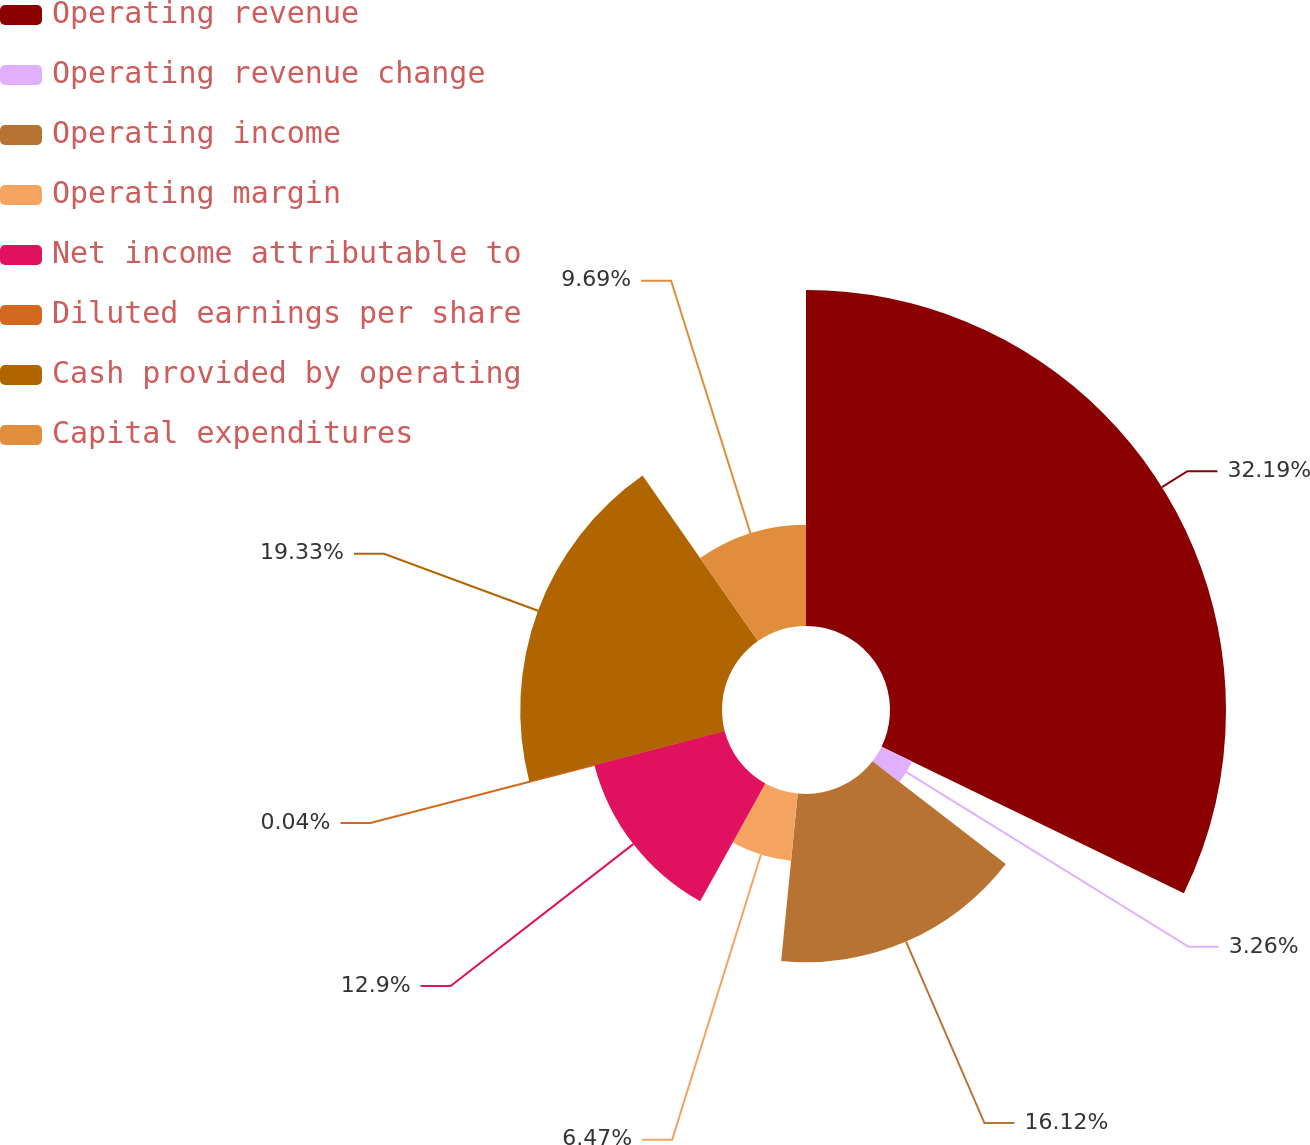Convert chart to OTSL. <chart><loc_0><loc_0><loc_500><loc_500><pie_chart><fcel>Operating revenue<fcel>Operating revenue change<fcel>Operating income<fcel>Operating margin<fcel>Net income attributable to<fcel>Diluted earnings per share<fcel>Cash provided by operating<fcel>Capital expenditures<nl><fcel>32.19%<fcel>3.26%<fcel>16.12%<fcel>6.47%<fcel>12.9%<fcel>0.04%<fcel>19.33%<fcel>9.69%<nl></chart> 